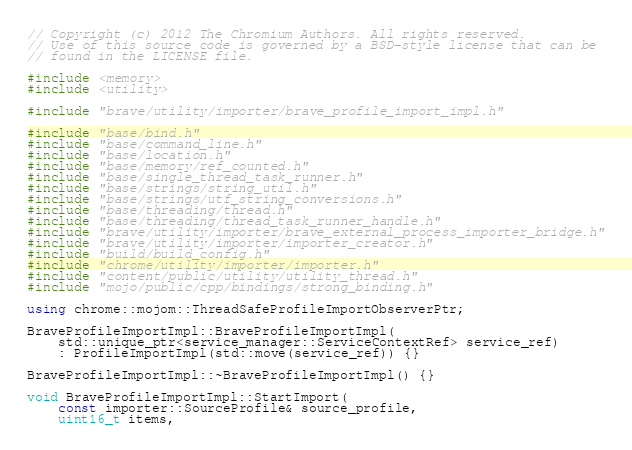Convert code to text. <code><loc_0><loc_0><loc_500><loc_500><_C++_>// Copyright (c) 2012 The Chromium Authors. All rights reserved.
// Use of this source code is governed by a BSD-style license that can be
// found in the LICENSE file.

#include <memory>
#include <utility>

#include "brave/utility/importer/brave_profile_import_impl.h"

#include "base/bind.h"
#include "base/command_line.h"
#include "base/location.h"
#include "base/memory/ref_counted.h"
#include "base/single_thread_task_runner.h"
#include "base/strings/string_util.h"
#include "base/strings/utf_string_conversions.h"
#include "base/threading/thread.h"
#include "base/threading/thread_task_runner_handle.h"
#include "brave/utility/importer/brave_external_process_importer_bridge.h"
#include "brave/utility/importer/importer_creator.h"
#include "build/build_config.h"
#include "chrome/utility/importer/importer.h"
#include "content/public/utility/utility_thread.h"
#include "mojo/public/cpp/bindings/strong_binding.h"

using chrome::mojom::ThreadSafeProfileImportObserverPtr;

BraveProfileImportImpl::BraveProfileImportImpl(
    std::unique_ptr<service_manager::ServiceContextRef> service_ref)
    : ProfileImportImpl(std::move(service_ref)) {}

BraveProfileImportImpl::~BraveProfileImportImpl() {}

void BraveProfileImportImpl::StartImport(
    const importer::SourceProfile& source_profile,
    uint16_t items,</code> 